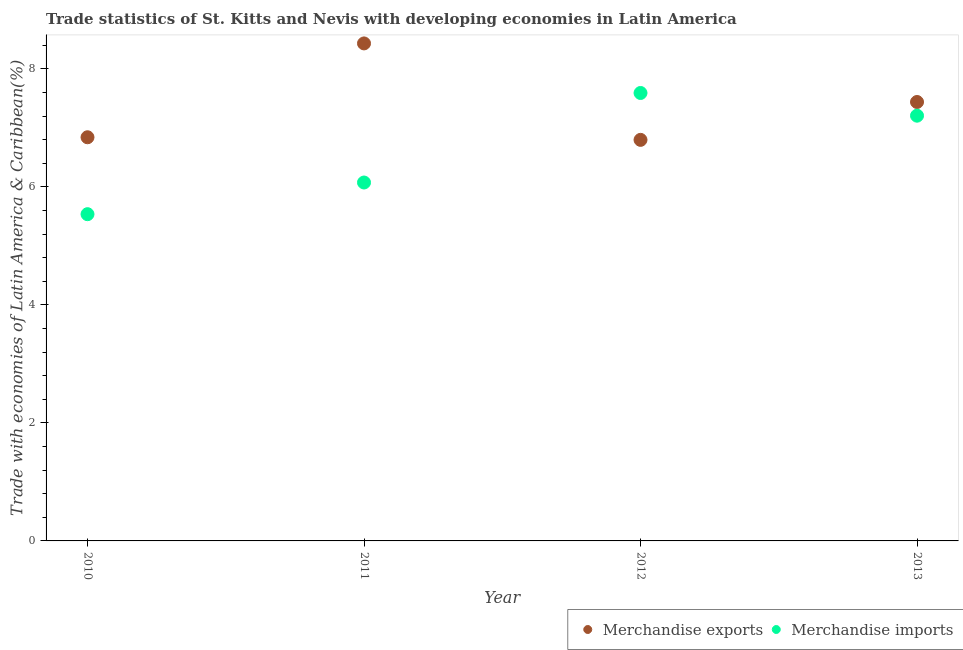Is the number of dotlines equal to the number of legend labels?
Your answer should be compact. Yes. What is the merchandise exports in 2011?
Your answer should be compact. 8.43. Across all years, what is the maximum merchandise exports?
Offer a terse response. 8.43. Across all years, what is the minimum merchandise exports?
Give a very brief answer. 6.8. What is the total merchandise imports in the graph?
Ensure brevity in your answer.  26.42. What is the difference between the merchandise exports in 2012 and that in 2013?
Your response must be concise. -0.64. What is the difference between the merchandise exports in 2010 and the merchandise imports in 2013?
Your answer should be very brief. -0.37. What is the average merchandise exports per year?
Your answer should be compact. 7.38. In the year 2012, what is the difference between the merchandise imports and merchandise exports?
Keep it short and to the point. 0.79. What is the ratio of the merchandise exports in 2010 to that in 2011?
Keep it short and to the point. 0.81. Is the merchandise imports in 2011 less than that in 2012?
Provide a short and direct response. Yes. What is the difference between the highest and the second highest merchandise exports?
Offer a very short reply. 0.99. What is the difference between the highest and the lowest merchandise exports?
Keep it short and to the point. 1.64. Is the merchandise imports strictly greater than the merchandise exports over the years?
Provide a short and direct response. No. Is the merchandise imports strictly less than the merchandise exports over the years?
Provide a short and direct response. No. Are the values on the major ticks of Y-axis written in scientific E-notation?
Your answer should be very brief. No. Where does the legend appear in the graph?
Offer a very short reply. Bottom right. How are the legend labels stacked?
Give a very brief answer. Horizontal. What is the title of the graph?
Provide a succinct answer. Trade statistics of St. Kitts and Nevis with developing economies in Latin America. What is the label or title of the X-axis?
Offer a terse response. Year. What is the label or title of the Y-axis?
Ensure brevity in your answer.  Trade with economies of Latin America & Caribbean(%). What is the Trade with economies of Latin America & Caribbean(%) of Merchandise exports in 2010?
Offer a terse response. 6.84. What is the Trade with economies of Latin America & Caribbean(%) in Merchandise imports in 2010?
Provide a short and direct response. 5.54. What is the Trade with economies of Latin America & Caribbean(%) of Merchandise exports in 2011?
Keep it short and to the point. 8.43. What is the Trade with economies of Latin America & Caribbean(%) of Merchandise imports in 2011?
Your answer should be very brief. 6.08. What is the Trade with economies of Latin America & Caribbean(%) in Merchandise exports in 2012?
Ensure brevity in your answer.  6.8. What is the Trade with economies of Latin America & Caribbean(%) of Merchandise imports in 2012?
Ensure brevity in your answer.  7.59. What is the Trade with economies of Latin America & Caribbean(%) in Merchandise exports in 2013?
Provide a succinct answer. 7.44. What is the Trade with economies of Latin America & Caribbean(%) of Merchandise imports in 2013?
Your response must be concise. 7.21. Across all years, what is the maximum Trade with economies of Latin America & Caribbean(%) in Merchandise exports?
Provide a short and direct response. 8.43. Across all years, what is the maximum Trade with economies of Latin America & Caribbean(%) in Merchandise imports?
Your answer should be very brief. 7.59. Across all years, what is the minimum Trade with economies of Latin America & Caribbean(%) of Merchandise exports?
Your response must be concise. 6.8. Across all years, what is the minimum Trade with economies of Latin America & Caribbean(%) in Merchandise imports?
Give a very brief answer. 5.54. What is the total Trade with economies of Latin America & Caribbean(%) in Merchandise exports in the graph?
Offer a very short reply. 29.52. What is the total Trade with economies of Latin America & Caribbean(%) of Merchandise imports in the graph?
Your answer should be compact. 26.42. What is the difference between the Trade with economies of Latin America & Caribbean(%) of Merchandise exports in 2010 and that in 2011?
Provide a succinct answer. -1.59. What is the difference between the Trade with economies of Latin America & Caribbean(%) in Merchandise imports in 2010 and that in 2011?
Provide a succinct answer. -0.54. What is the difference between the Trade with economies of Latin America & Caribbean(%) in Merchandise exports in 2010 and that in 2012?
Your response must be concise. 0.04. What is the difference between the Trade with economies of Latin America & Caribbean(%) of Merchandise imports in 2010 and that in 2012?
Your answer should be very brief. -2.05. What is the difference between the Trade with economies of Latin America & Caribbean(%) in Merchandise exports in 2010 and that in 2013?
Give a very brief answer. -0.6. What is the difference between the Trade with economies of Latin America & Caribbean(%) in Merchandise imports in 2010 and that in 2013?
Ensure brevity in your answer.  -1.67. What is the difference between the Trade with economies of Latin America & Caribbean(%) of Merchandise exports in 2011 and that in 2012?
Your answer should be very brief. 1.64. What is the difference between the Trade with economies of Latin America & Caribbean(%) of Merchandise imports in 2011 and that in 2012?
Give a very brief answer. -1.52. What is the difference between the Trade with economies of Latin America & Caribbean(%) in Merchandise exports in 2011 and that in 2013?
Offer a very short reply. 0.99. What is the difference between the Trade with economies of Latin America & Caribbean(%) in Merchandise imports in 2011 and that in 2013?
Your answer should be very brief. -1.13. What is the difference between the Trade with economies of Latin America & Caribbean(%) in Merchandise exports in 2012 and that in 2013?
Ensure brevity in your answer.  -0.64. What is the difference between the Trade with economies of Latin America & Caribbean(%) in Merchandise imports in 2012 and that in 2013?
Provide a short and direct response. 0.38. What is the difference between the Trade with economies of Latin America & Caribbean(%) in Merchandise exports in 2010 and the Trade with economies of Latin America & Caribbean(%) in Merchandise imports in 2011?
Your answer should be compact. 0.77. What is the difference between the Trade with economies of Latin America & Caribbean(%) of Merchandise exports in 2010 and the Trade with economies of Latin America & Caribbean(%) of Merchandise imports in 2012?
Offer a very short reply. -0.75. What is the difference between the Trade with economies of Latin America & Caribbean(%) in Merchandise exports in 2010 and the Trade with economies of Latin America & Caribbean(%) in Merchandise imports in 2013?
Your response must be concise. -0.37. What is the difference between the Trade with economies of Latin America & Caribbean(%) of Merchandise exports in 2011 and the Trade with economies of Latin America & Caribbean(%) of Merchandise imports in 2012?
Give a very brief answer. 0.84. What is the difference between the Trade with economies of Latin America & Caribbean(%) in Merchandise exports in 2011 and the Trade with economies of Latin America & Caribbean(%) in Merchandise imports in 2013?
Offer a very short reply. 1.23. What is the difference between the Trade with economies of Latin America & Caribbean(%) in Merchandise exports in 2012 and the Trade with economies of Latin America & Caribbean(%) in Merchandise imports in 2013?
Give a very brief answer. -0.41. What is the average Trade with economies of Latin America & Caribbean(%) in Merchandise exports per year?
Give a very brief answer. 7.38. What is the average Trade with economies of Latin America & Caribbean(%) in Merchandise imports per year?
Offer a very short reply. 6.6. In the year 2010, what is the difference between the Trade with economies of Latin America & Caribbean(%) in Merchandise exports and Trade with economies of Latin America & Caribbean(%) in Merchandise imports?
Your answer should be compact. 1.3. In the year 2011, what is the difference between the Trade with economies of Latin America & Caribbean(%) of Merchandise exports and Trade with economies of Latin America & Caribbean(%) of Merchandise imports?
Your answer should be compact. 2.36. In the year 2012, what is the difference between the Trade with economies of Latin America & Caribbean(%) in Merchandise exports and Trade with economies of Latin America & Caribbean(%) in Merchandise imports?
Make the answer very short. -0.79. In the year 2013, what is the difference between the Trade with economies of Latin America & Caribbean(%) in Merchandise exports and Trade with economies of Latin America & Caribbean(%) in Merchandise imports?
Your answer should be very brief. 0.23. What is the ratio of the Trade with economies of Latin America & Caribbean(%) in Merchandise exports in 2010 to that in 2011?
Your response must be concise. 0.81. What is the ratio of the Trade with economies of Latin America & Caribbean(%) of Merchandise imports in 2010 to that in 2011?
Provide a short and direct response. 0.91. What is the ratio of the Trade with economies of Latin America & Caribbean(%) in Merchandise imports in 2010 to that in 2012?
Your answer should be very brief. 0.73. What is the ratio of the Trade with economies of Latin America & Caribbean(%) of Merchandise exports in 2010 to that in 2013?
Your answer should be compact. 0.92. What is the ratio of the Trade with economies of Latin America & Caribbean(%) in Merchandise imports in 2010 to that in 2013?
Provide a succinct answer. 0.77. What is the ratio of the Trade with economies of Latin America & Caribbean(%) of Merchandise exports in 2011 to that in 2012?
Your answer should be compact. 1.24. What is the ratio of the Trade with economies of Latin America & Caribbean(%) of Merchandise imports in 2011 to that in 2012?
Offer a terse response. 0.8. What is the ratio of the Trade with economies of Latin America & Caribbean(%) in Merchandise exports in 2011 to that in 2013?
Ensure brevity in your answer.  1.13. What is the ratio of the Trade with economies of Latin America & Caribbean(%) in Merchandise imports in 2011 to that in 2013?
Give a very brief answer. 0.84. What is the ratio of the Trade with economies of Latin America & Caribbean(%) of Merchandise exports in 2012 to that in 2013?
Keep it short and to the point. 0.91. What is the ratio of the Trade with economies of Latin America & Caribbean(%) in Merchandise imports in 2012 to that in 2013?
Your answer should be very brief. 1.05. What is the difference between the highest and the second highest Trade with economies of Latin America & Caribbean(%) in Merchandise exports?
Provide a succinct answer. 0.99. What is the difference between the highest and the second highest Trade with economies of Latin America & Caribbean(%) in Merchandise imports?
Offer a terse response. 0.38. What is the difference between the highest and the lowest Trade with economies of Latin America & Caribbean(%) in Merchandise exports?
Your answer should be very brief. 1.64. What is the difference between the highest and the lowest Trade with economies of Latin America & Caribbean(%) in Merchandise imports?
Provide a succinct answer. 2.05. 